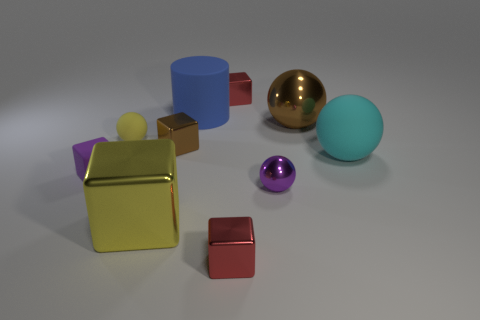There is a small red cube behind the big blue rubber thing on the left side of the big metallic ball; how many yellow matte things are to the right of it? 0 